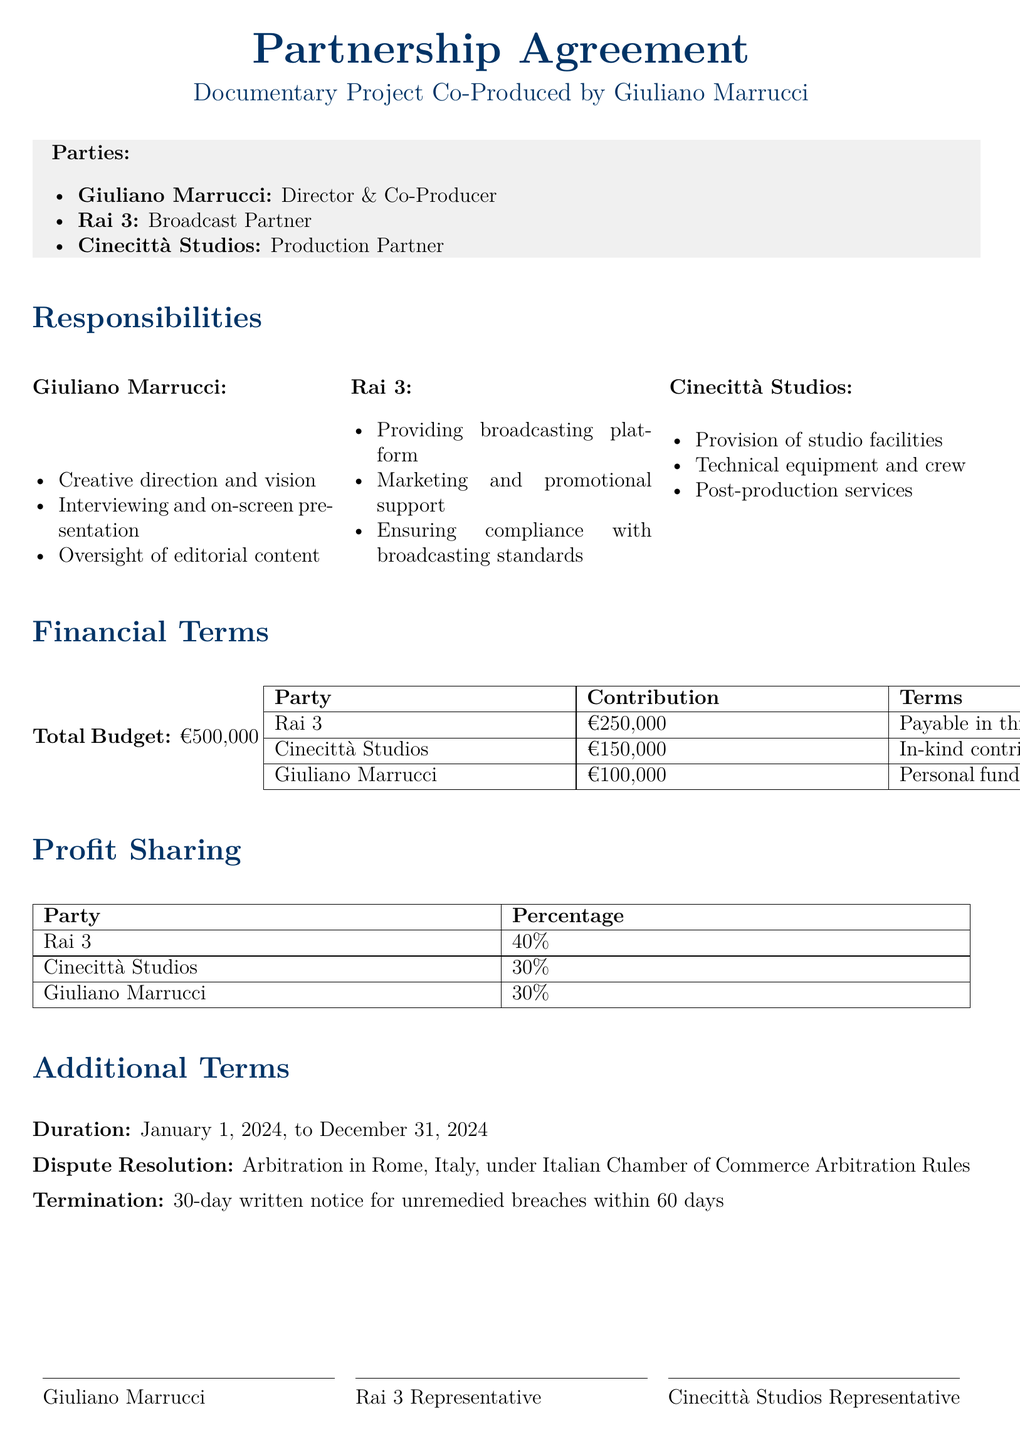What is the total budget for the project? The total budget is specified in the financial terms section of the document.
Answer: €500,000 Who is responsible for providing the broadcasting platform? This responsibility is detailed under Rai 3's section.
Answer: Rai 3 What is Giuliano Marrucci's role in the project? His role is outlined in the responsibilities section.
Answer: Director & Co-Producer How much will Rai 3 contribute to the project? The contribution is listed in the financial terms section of the document.
Answer: €250,000 What is the profit-sharing percentage for Cinecittà Studios? This is specified in the profit-sharing table.
Answer: 30% What is the duration of the partnership agreement? The duration is mentioned in the additional terms section.
Answer: January 1, 2024, to December 31, 2024 Where will disputes be resolved? This is stated under the dispute resolution section of the document.
Answer: Rome, Italy What type of contributions will Cinecittà Studios provide? This information is found in the financial terms section.
Answer: In-kind contribution What is required for termination of the agreement? The termination conditions are listed in the additional terms section.
Answer: 30-day written notice for unremedied breaches within 60 days 